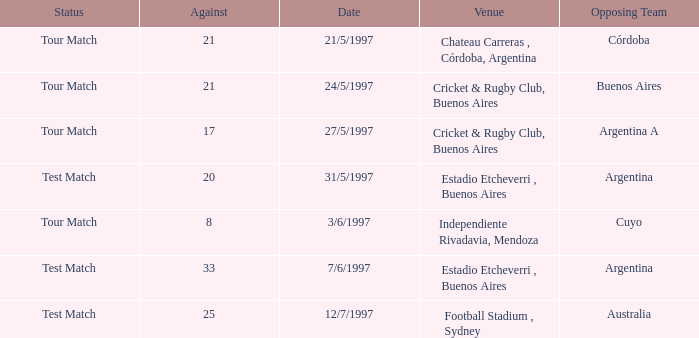What is the status of the match held on 12/7/1997? Test Match. 